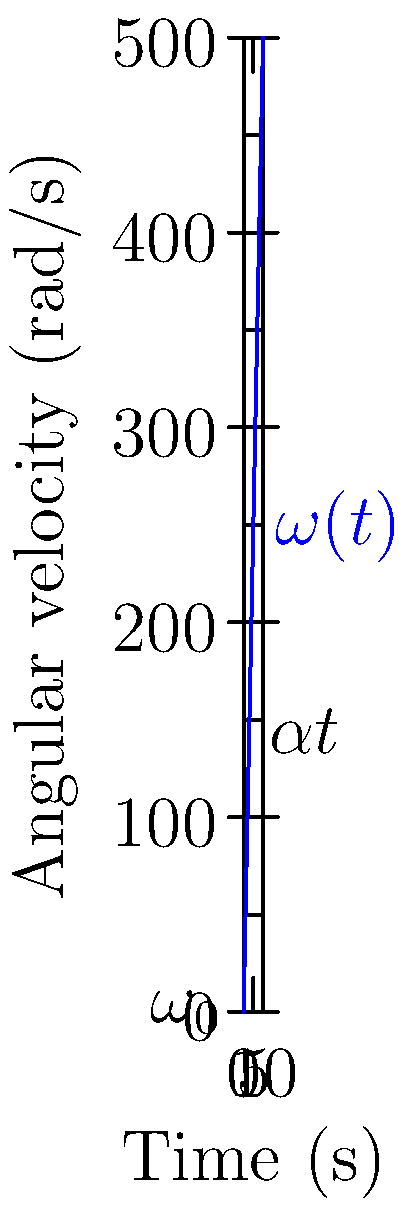A centrifuge used in enzyme purification is accelerating from rest with a constant angular acceleration of 50 rad/s². After 8 seconds, what is its angular velocity? To solve this problem, we'll use the equation for angular velocity with constant angular acceleration:

$$\omega(t) = \omega_0 + \alpha t$$

Where:
- $\omega(t)$ is the angular velocity at time $t$
- $\omega_0$ is the initial angular velocity
- $\alpha$ is the angular acceleration
- $t$ is the time elapsed

Given:
- Initial angular velocity $\omega_0 = 0$ (starting from rest)
- Angular acceleration $\alpha = 50$ rad/s²
- Time $t = 8$ s

Let's substitute these values into the equation:

$$\omega(8) = 0 + 50 \cdot 8$$

$$\omega(8) = 400 \text{ rad/s}$$

Therefore, after 8 seconds, the centrifuge's angular velocity is 400 rad/s.
Answer: 400 rad/s 